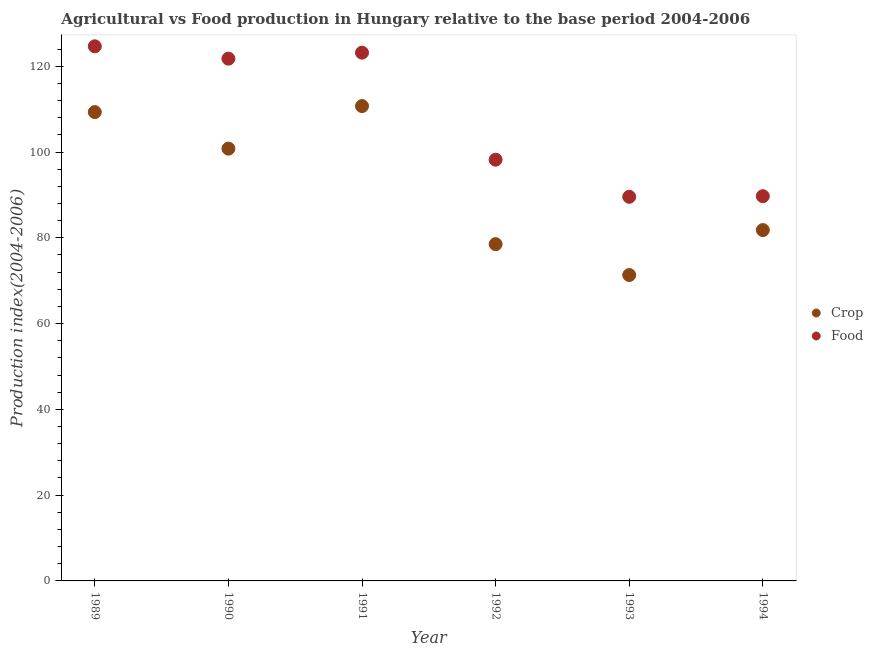How many different coloured dotlines are there?
Your answer should be very brief. 2. Is the number of dotlines equal to the number of legend labels?
Your answer should be very brief. Yes. What is the crop production index in 1992?
Offer a terse response. 78.53. Across all years, what is the maximum crop production index?
Offer a very short reply. 110.72. Across all years, what is the minimum food production index?
Your answer should be compact. 89.57. In which year was the crop production index maximum?
Ensure brevity in your answer.  1991. In which year was the crop production index minimum?
Ensure brevity in your answer.  1993. What is the total crop production index in the graph?
Offer a terse response. 552.51. What is the difference between the food production index in 1989 and that in 1993?
Keep it short and to the point. 35.09. What is the difference between the food production index in 1989 and the crop production index in 1992?
Provide a succinct answer. 46.13. What is the average food production index per year?
Your response must be concise. 107.85. In the year 1994, what is the difference between the food production index and crop production index?
Your answer should be compact. 7.9. What is the ratio of the crop production index in 1990 to that in 1994?
Keep it short and to the point. 1.23. Is the food production index in 1989 less than that in 1993?
Keep it short and to the point. No. Is the difference between the food production index in 1989 and 1990 greater than the difference between the crop production index in 1989 and 1990?
Your answer should be compact. No. What is the difference between the highest and the second highest food production index?
Offer a very short reply. 1.48. What is the difference between the highest and the lowest food production index?
Give a very brief answer. 35.09. Does the crop production index monotonically increase over the years?
Your answer should be compact. No. Is the crop production index strictly greater than the food production index over the years?
Give a very brief answer. No. How many years are there in the graph?
Provide a succinct answer. 6. Are the values on the major ticks of Y-axis written in scientific E-notation?
Your response must be concise. No. What is the title of the graph?
Keep it short and to the point. Agricultural vs Food production in Hungary relative to the base period 2004-2006. Does "Agricultural land" appear as one of the legend labels in the graph?
Offer a terse response. No. What is the label or title of the X-axis?
Your answer should be compact. Year. What is the label or title of the Y-axis?
Provide a short and direct response. Production index(2004-2006). What is the Production index(2004-2006) in Crop in 1989?
Offer a very short reply. 109.32. What is the Production index(2004-2006) in Food in 1989?
Keep it short and to the point. 124.66. What is the Production index(2004-2006) in Crop in 1990?
Ensure brevity in your answer.  100.8. What is the Production index(2004-2006) in Food in 1990?
Your answer should be very brief. 121.78. What is the Production index(2004-2006) of Crop in 1991?
Your answer should be very brief. 110.72. What is the Production index(2004-2006) of Food in 1991?
Make the answer very short. 123.18. What is the Production index(2004-2006) of Crop in 1992?
Offer a very short reply. 78.53. What is the Production index(2004-2006) of Food in 1992?
Ensure brevity in your answer.  98.22. What is the Production index(2004-2006) in Crop in 1993?
Your response must be concise. 71.33. What is the Production index(2004-2006) of Food in 1993?
Give a very brief answer. 89.57. What is the Production index(2004-2006) of Crop in 1994?
Ensure brevity in your answer.  81.81. What is the Production index(2004-2006) in Food in 1994?
Your answer should be very brief. 89.71. Across all years, what is the maximum Production index(2004-2006) of Crop?
Provide a short and direct response. 110.72. Across all years, what is the maximum Production index(2004-2006) in Food?
Your response must be concise. 124.66. Across all years, what is the minimum Production index(2004-2006) in Crop?
Provide a succinct answer. 71.33. Across all years, what is the minimum Production index(2004-2006) of Food?
Keep it short and to the point. 89.57. What is the total Production index(2004-2006) in Crop in the graph?
Keep it short and to the point. 552.51. What is the total Production index(2004-2006) in Food in the graph?
Provide a succinct answer. 647.12. What is the difference between the Production index(2004-2006) of Crop in 1989 and that in 1990?
Give a very brief answer. 8.52. What is the difference between the Production index(2004-2006) in Food in 1989 and that in 1990?
Offer a terse response. 2.88. What is the difference between the Production index(2004-2006) of Food in 1989 and that in 1991?
Your answer should be compact. 1.48. What is the difference between the Production index(2004-2006) of Crop in 1989 and that in 1992?
Your answer should be compact. 30.79. What is the difference between the Production index(2004-2006) in Food in 1989 and that in 1992?
Your answer should be compact. 26.44. What is the difference between the Production index(2004-2006) of Crop in 1989 and that in 1993?
Give a very brief answer. 37.99. What is the difference between the Production index(2004-2006) of Food in 1989 and that in 1993?
Offer a terse response. 35.09. What is the difference between the Production index(2004-2006) in Crop in 1989 and that in 1994?
Provide a succinct answer. 27.51. What is the difference between the Production index(2004-2006) in Food in 1989 and that in 1994?
Offer a terse response. 34.95. What is the difference between the Production index(2004-2006) of Crop in 1990 and that in 1991?
Provide a succinct answer. -9.92. What is the difference between the Production index(2004-2006) of Food in 1990 and that in 1991?
Your answer should be compact. -1.4. What is the difference between the Production index(2004-2006) of Crop in 1990 and that in 1992?
Provide a succinct answer. 22.27. What is the difference between the Production index(2004-2006) of Food in 1990 and that in 1992?
Provide a short and direct response. 23.56. What is the difference between the Production index(2004-2006) of Crop in 1990 and that in 1993?
Keep it short and to the point. 29.47. What is the difference between the Production index(2004-2006) in Food in 1990 and that in 1993?
Your answer should be compact. 32.21. What is the difference between the Production index(2004-2006) of Crop in 1990 and that in 1994?
Provide a succinct answer. 18.99. What is the difference between the Production index(2004-2006) in Food in 1990 and that in 1994?
Your answer should be very brief. 32.07. What is the difference between the Production index(2004-2006) in Crop in 1991 and that in 1992?
Keep it short and to the point. 32.19. What is the difference between the Production index(2004-2006) of Food in 1991 and that in 1992?
Your answer should be compact. 24.96. What is the difference between the Production index(2004-2006) of Crop in 1991 and that in 1993?
Your answer should be very brief. 39.39. What is the difference between the Production index(2004-2006) of Food in 1991 and that in 1993?
Ensure brevity in your answer.  33.61. What is the difference between the Production index(2004-2006) of Crop in 1991 and that in 1994?
Offer a terse response. 28.91. What is the difference between the Production index(2004-2006) of Food in 1991 and that in 1994?
Keep it short and to the point. 33.47. What is the difference between the Production index(2004-2006) of Food in 1992 and that in 1993?
Offer a terse response. 8.65. What is the difference between the Production index(2004-2006) of Crop in 1992 and that in 1994?
Give a very brief answer. -3.28. What is the difference between the Production index(2004-2006) of Food in 1992 and that in 1994?
Give a very brief answer. 8.51. What is the difference between the Production index(2004-2006) in Crop in 1993 and that in 1994?
Offer a terse response. -10.48. What is the difference between the Production index(2004-2006) of Food in 1993 and that in 1994?
Your answer should be very brief. -0.14. What is the difference between the Production index(2004-2006) in Crop in 1989 and the Production index(2004-2006) in Food in 1990?
Your answer should be compact. -12.46. What is the difference between the Production index(2004-2006) of Crop in 1989 and the Production index(2004-2006) of Food in 1991?
Your answer should be compact. -13.86. What is the difference between the Production index(2004-2006) of Crop in 1989 and the Production index(2004-2006) of Food in 1992?
Your response must be concise. 11.1. What is the difference between the Production index(2004-2006) of Crop in 1989 and the Production index(2004-2006) of Food in 1993?
Give a very brief answer. 19.75. What is the difference between the Production index(2004-2006) of Crop in 1989 and the Production index(2004-2006) of Food in 1994?
Offer a very short reply. 19.61. What is the difference between the Production index(2004-2006) in Crop in 1990 and the Production index(2004-2006) in Food in 1991?
Your response must be concise. -22.38. What is the difference between the Production index(2004-2006) of Crop in 1990 and the Production index(2004-2006) of Food in 1992?
Provide a short and direct response. 2.58. What is the difference between the Production index(2004-2006) of Crop in 1990 and the Production index(2004-2006) of Food in 1993?
Make the answer very short. 11.23. What is the difference between the Production index(2004-2006) in Crop in 1990 and the Production index(2004-2006) in Food in 1994?
Ensure brevity in your answer.  11.09. What is the difference between the Production index(2004-2006) of Crop in 1991 and the Production index(2004-2006) of Food in 1993?
Your response must be concise. 21.15. What is the difference between the Production index(2004-2006) of Crop in 1991 and the Production index(2004-2006) of Food in 1994?
Offer a terse response. 21.01. What is the difference between the Production index(2004-2006) in Crop in 1992 and the Production index(2004-2006) in Food in 1993?
Keep it short and to the point. -11.04. What is the difference between the Production index(2004-2006) of Crop in 1992 and the Production index(2004-2006) of Food in 1994?
Keep it short and to the point. -11.18. What is the difference between the Production index(2004-2006) of Crop in 1993 and the Production index(2004-2006) of Food in 1994?
Offer a very short reply. -18.38. What is the average Production index(2004-2006) of Crop per year?
Give a very brief answer. 92.08. What is the average Production index(2004-2006) of Food per year?
Offer a terse response. 107.85. In the year 1989, what is the difference between the Production index(2004-2006) in Crop and Production index(2004-2006) in Food?
Your answer should be very brief. -15.34. In the year 1990, what is the difference between the Production index(2004-2006) in Crop and Production index(2004-2006) in Food?
Offer a terse response. -20.98. In the year 1991, what is the difference between the Production index(2004-2006) in Crop and Production index(2004-2006) in Food?
Offer a very short reply. -12.46. In the year 1992, what is the difference between the Production index(2004-2006) in Crop and Production index(2004-2006) in Food?
Make the answer very short. -19.69. In the year 1993, what is the difference between the Production index(2004-2006) in Crop and Production index(2004-2006) in Food?
Provide a succinct answer. -18.24. In the year 1994, what is the difference between the Production index(2004-2006) of Crop and Production index(2004-2006) of Food?
Ensure brevity in your answer.  -7.9. What is the ratio of the Production index(2004-2006) of Crop in 1989 to that in 1990?
Ensure brevity in your answer.  1.08. What is the ratio of the Production index(2004-2006) of Food in 1989 to that in 1990?
Provide a short and direct response. 1.02. What is the ratio of the Production index(2004-2006) in Crop in 1989 to that in 1991?
Your response must be concise. 0.99. What is the ratio of the Production index(2004-2006) of Crop in 1989 to that in 1992?
Provide a succinct answer. 1.39. What is the ratio of the Production index(2004-2006) in Food in 1989 to that in 1992?
Offer a very short reply. 1.27. What is the ratio of the Production index(2004-2006) of Crop in 1989 to that in 1993?
Keep it short and to the point. 1.53. What is the ratio of the Production index(2004-2006) in Food in 1989 to that in 1993?
Your answer should be very brief. 1.39. What is the ratio of the Production index(2004-2006) of Crop in 1989 to that in 1994?
Make the answer very short. 1.34. What is the ratio of the Production index(2004-2006) in Food in 1989 to that in 1994?
Your answer should be very brief. 1.39. What is the ratio of the Production index(2004-2006) in Crop in 1990 to that in 1991?
Ensure brevity in your answer.  0.91. What is the ratio of the Production index(2004-2006) in Crop in 1990 to that in 1992?
Your answer should be compact. 1.28. What is the ratio of the Production index(2004-2006) in Food in 1990 to that in 1992?
Make the answer very short. 1.24. What is the ratio of the Production index(2004-2006) in Crop in 1990 to that in 1993?
Ensure brevity in your answer.  1.41. What is the ratio of the Production index(2004-2006) of Food in 1990 to that in 1993?
Give a very brief answer. 1.36. What is the ratio of the Production index(2004-2006) in Crop in 1990 to that in 1994?
Make the answer very short. 1.23. What is the ratio of the Production index(2004-2006) in Food in 1990 to that in 1994?
Your answer should be compact. 1.36. What is the ratio of the Production index(2004-2006) in Crop in 1991 to that in 1992?
Provide a succinct answer. 1.41. What is the ratio of the Production index(2004-2006) in Food in 1991 to that in 1992?
Offer a terse response. 1.25. What is the ratio of the Production index(2004-2006) of Crop in 1991 to that in 1993?
Ensure brevity in your answer.  1.55. What is the ratio of the Production index(2004-2006) of Food in 1991 to that in 1993?
Make the answer very short. 1.38. What is the ratio of the Production index(2004-2006) of Crop in 1991 to that in 1994?
Ensure brevity in your answer.  1.35. What is the ratio of the Production index(2004-2006) in Food in 1991 to that in 1994?
Offer a terse response. 1.37. What is the ratio of the Production index(2004-2006) in Crop in 1992 to that in 1993?
Make the answer very short. 1.1. What is the ratio of the Production index(2004-2006) in Food in 1992 to that in 1993?
Provide a succinct answer. 1.1. What is the ratio of the Production index(2004-2006) of Crop in 1992 to that in 1994?
Provide a short and direct response. 0.96. What is the ratio of the Production index(2004-2006) in Food in 1992 to that in 1994?
Provide a succinct answer. 1.09. What is the ratio of the Production index(2004-2006) of Crop in 1993 to that in 1994?
Your response must be concise. 0.87. What is the difference between the highest and the second highest Production index(2004-2006) of Food?
Your response must be concise. 1.48. What is the difference between the highest and the lowest Production index(2004-2006) in Crop?
Provide a short and direct response. 39.39. What is the difference between the highest and the lowest Production index(2004-2006) in Food?
Offer a very short reply. 35.09. 